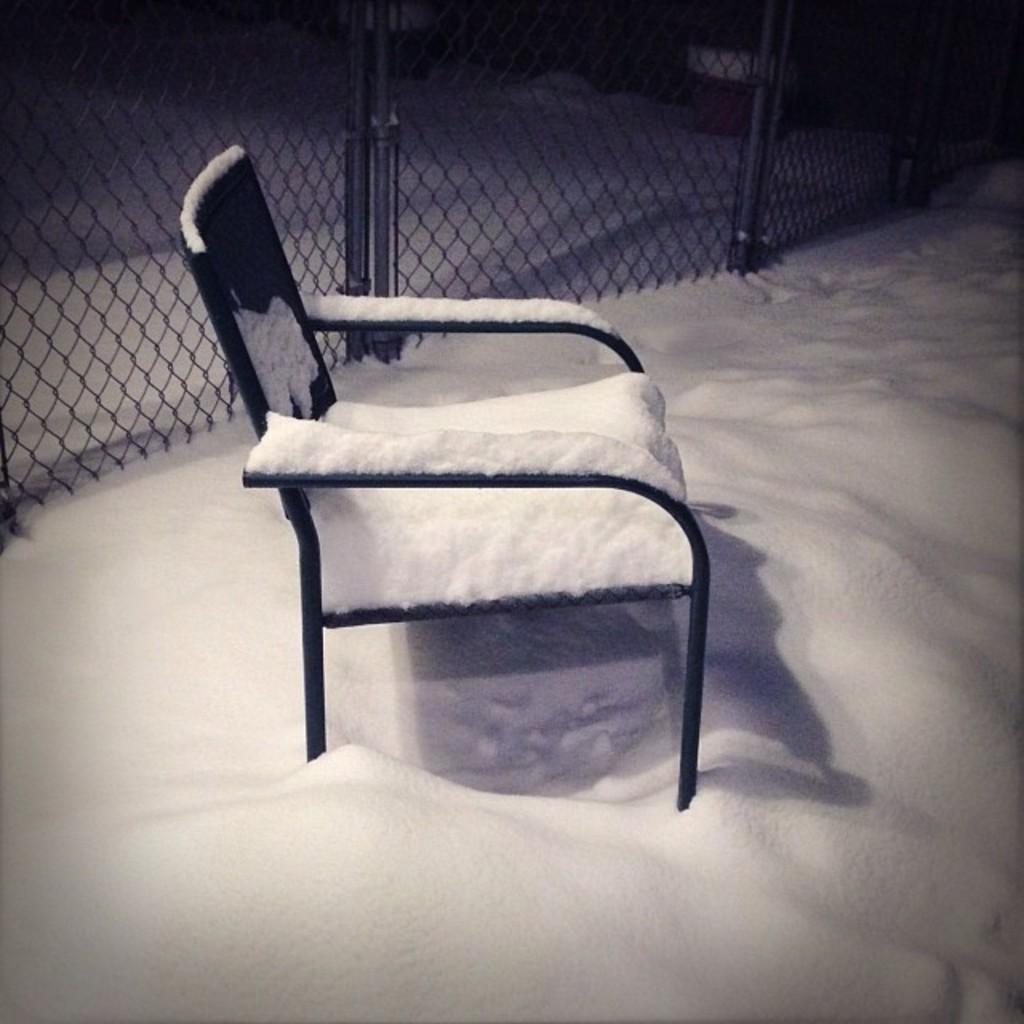Could you give a brief overview of what you see in this image? In this picture we can see snow, there is a chair in the middle, in the background we can see fencing. 